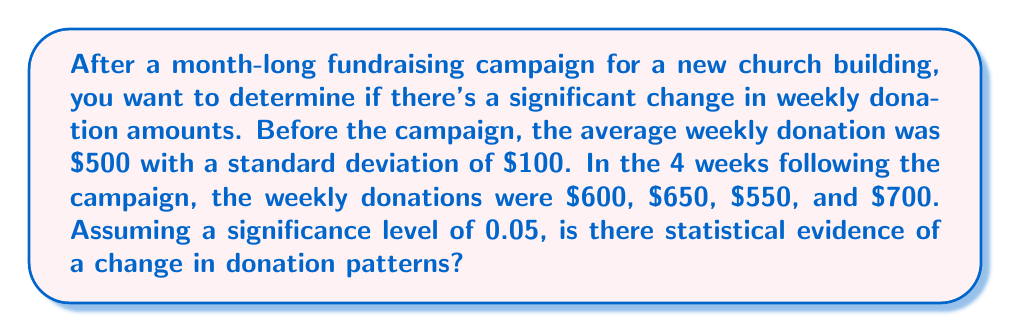Provide a solution to this math problem. To determine if there's a significant change in donation patterns, we'll use a one-sample t-test. Here are the steps:

1. State the null and alternative hypotheses:
   $H_0: \mu = 500$ (no change in donation patterns)
   $H_a: \mu \neq 500$ (there is a change in donation patterns)

2. Calculate the mean of the new donations:
   $\bar{x} = \frac{600 + 650 + 550 + 700}{4} = 625$

3. Calculate the standard error:
   $SE = \frac{s}{\sqrt{n}} = \frac{100}{\sqrt{4}} = 50$

4. Calculate the t-statistic:
   $t = \frac{\bar{x} - \mu_0}{SE} = \frac{625 - 500}{50} = 2.5$

5. Determine the critical t-value for a two-tailed test with 3 degrees of freedom (n-1) and α = 0.05:
   $t_{critical} = \pm 3.182$

6. Compare the calculated t-statistic to the critical value:
   $|2.5| < 3.182$

7. Calculate the p-value:
   Using a t-distribution calculator with 3 degrees of freedom, we find:
   $p-value \approx 0.0877$

8. Compare the p-value to the significance level:
   $0.0877 > 0.05$

Since the absolute value of the t-statistic is less than the critical value and the p-value is greater than the significance level, we fail to reject the null hypothesis.
Answer: Fail to reject $H_0$; insufficient evidence of a change in donation patterns (p = 0.0877). 